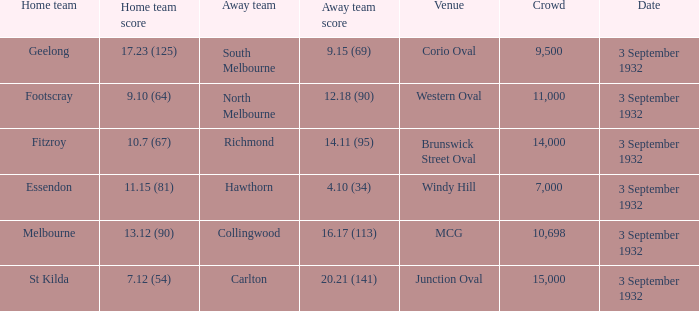What is the total Crowd number for the team that has an Away team score of 12.18 (90)? 11000.0. 